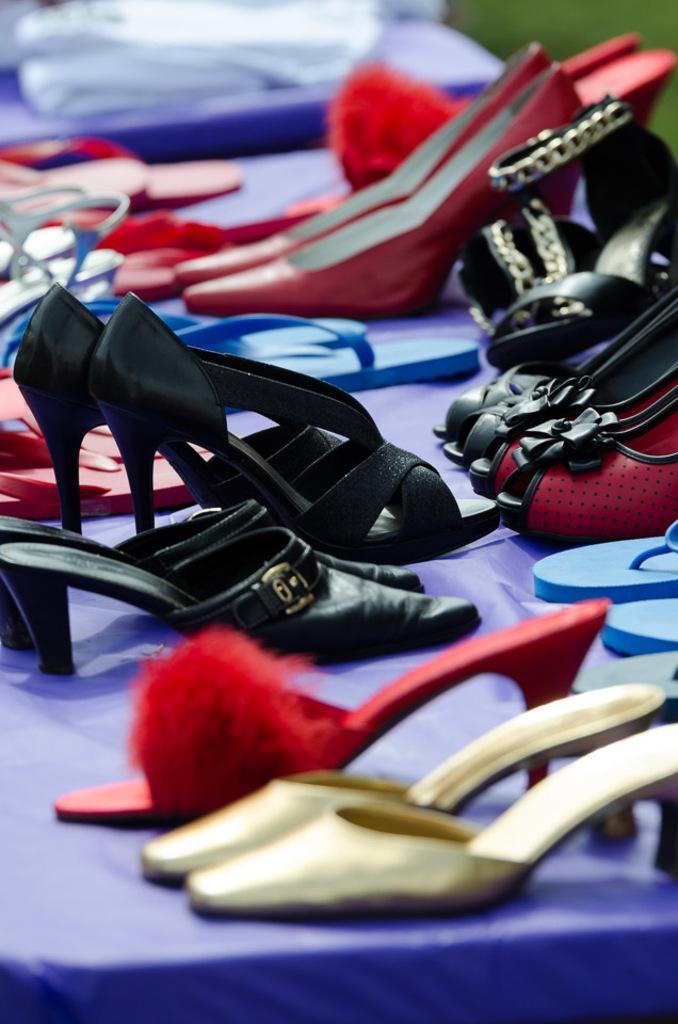How would you summarize this image in a sentence or two? In the middle of the image we can see some footwear. 